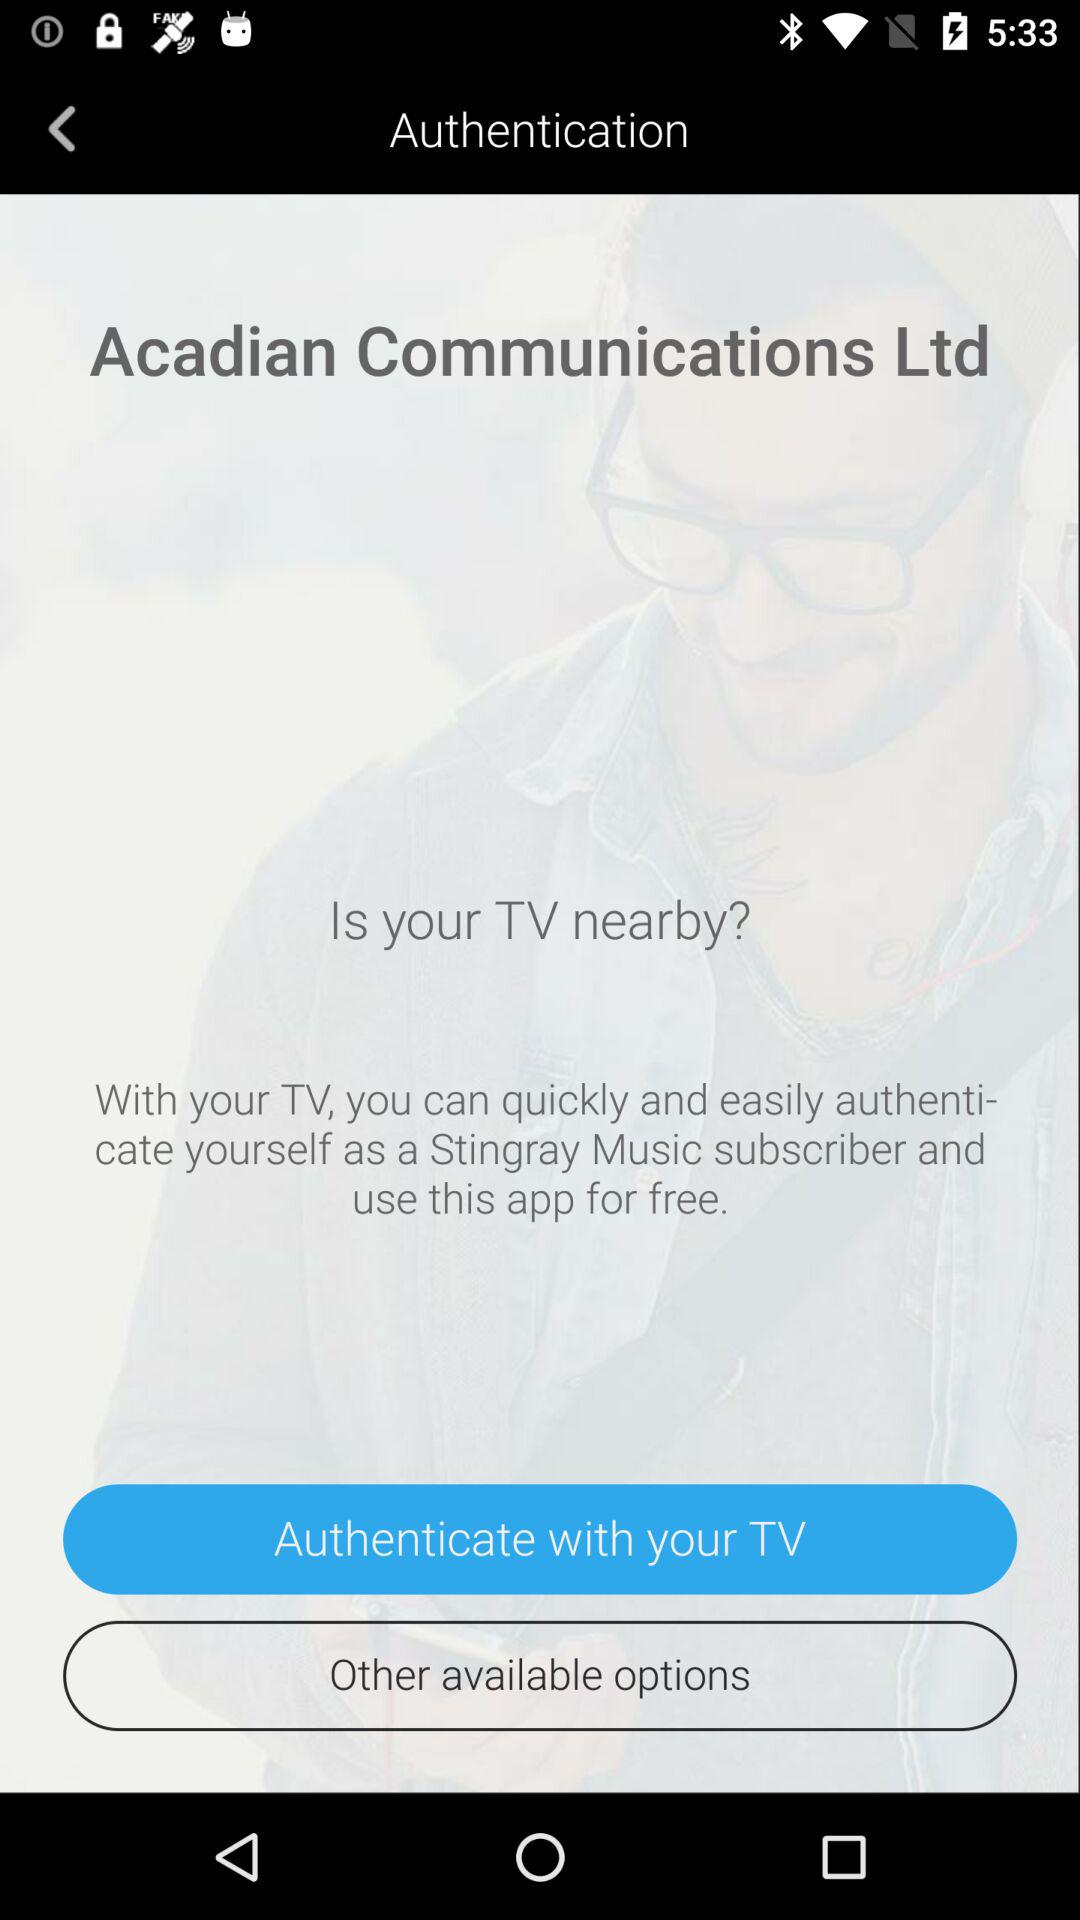What is the name of the application? The name of the application is "Stingray Music". 